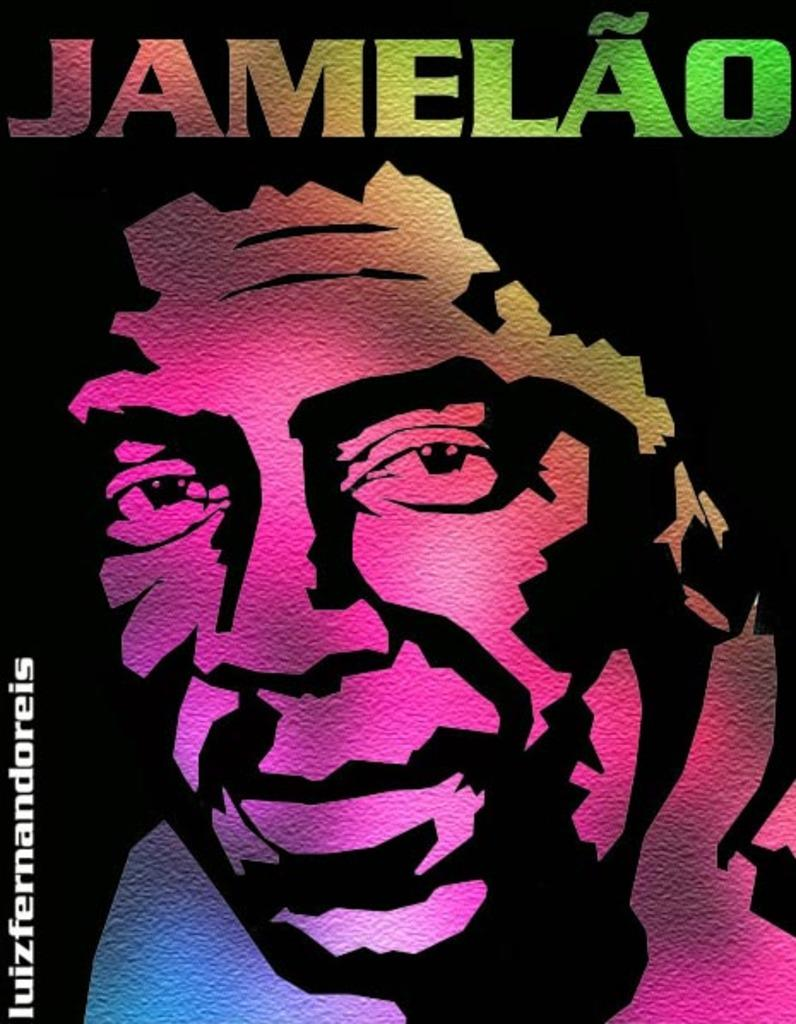What type of image is being described? The image is an animated picture. Can you describe the person in the image? The person in the image has multiple colors. What else can be found in the image besides the person? There is text present in the image. Reasoning: Let's think step by breaking down the facts step by step. First, we identify that the image is animated, which sets the context for the rest of the conversation. Next, we describe the person in the image, focusing on their unique characteristic of having multiple colors. Finally, we mention the presence of text in the image, which adds another layer of detail. Absurd Question/Answer: How does the person in the image handle the loss of their self? There is no indication of loss or self in the image, as it only features an animated person with multiple colors and text. 